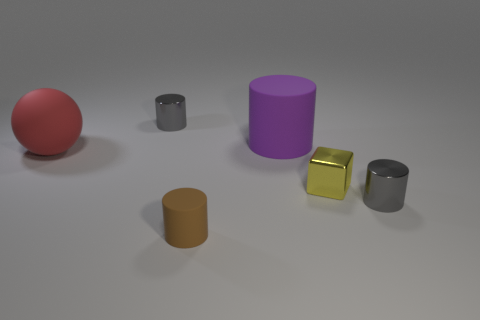The rubber sphere is what size?
Make the answer very short. Large. Is the matte ball the same size as the purple thing?
Make the answer very short. Yes. What is the big thing in front of the large purple cylinder made of?
Provide a short and direct response. Rubber. What material is the purple object that is the same shape as the tiny brown rubber thing?
Keep it short and to the point. Rubber. Are there any gray objects behind the tiny metallic cube right of the purple cylinder?
Offer a terse response. Yes. Is the shape of the tiny yellow thing the same as the large red thing?
Provide a succinct answer. No. There is a red thing that is the same material as the large cylinder; what shape is it?
Provide a short and direct response. Sphere. There is a metallic object to the left of the purple cylinder; is its size the same as the gray cylinder to the right of the small brown rubber cylinder?
Provide a short and direct response. Yes. Are there more matte cylinders right of the red thing than objects on the right side of the purple rubber cylinder?
Your answer should be compact. No. How many other things are there of the same color as the block?
Offer a very short reply. 0. 